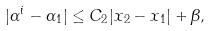Convert formula to latex. <formula><loc_0><loc_0><loc_500><loc_500>| \alpha ^ { i } - \alpha _ { 1 } | \leq C _ { 2 } | x _ { 2 } - x _ { 1 } | + \beta ,</formula> 